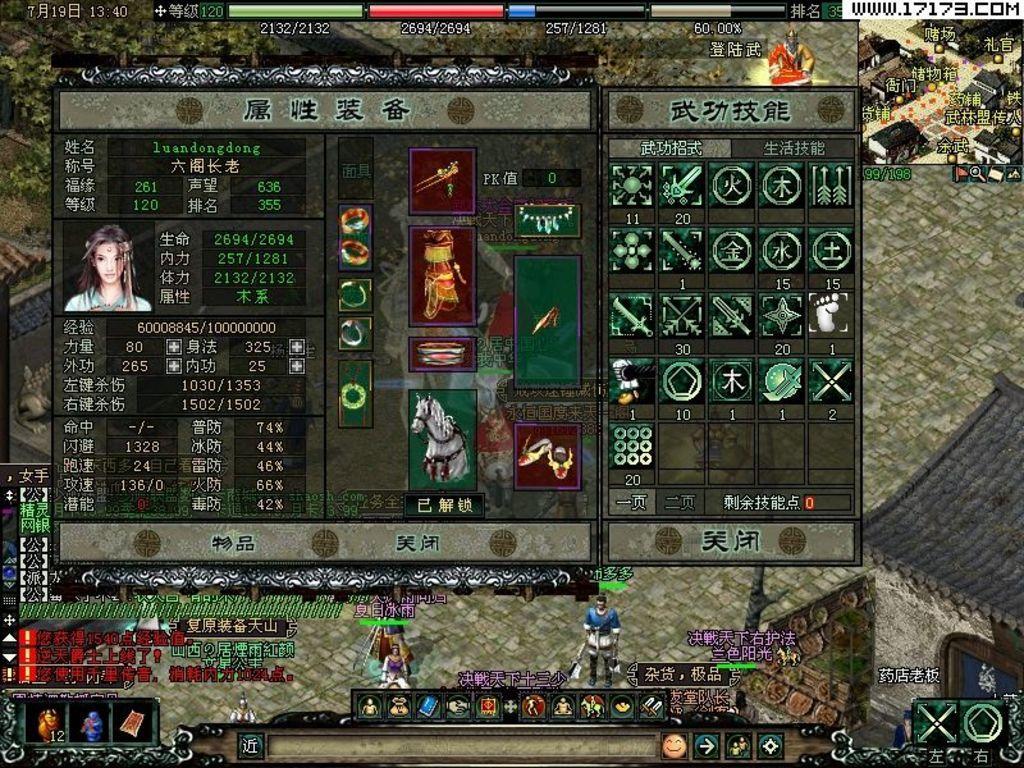How would you summarize this image in a sentence or two? In this image, we can see an animated picture. Here we can see few figures, some text, icons, house, few people in animation. 